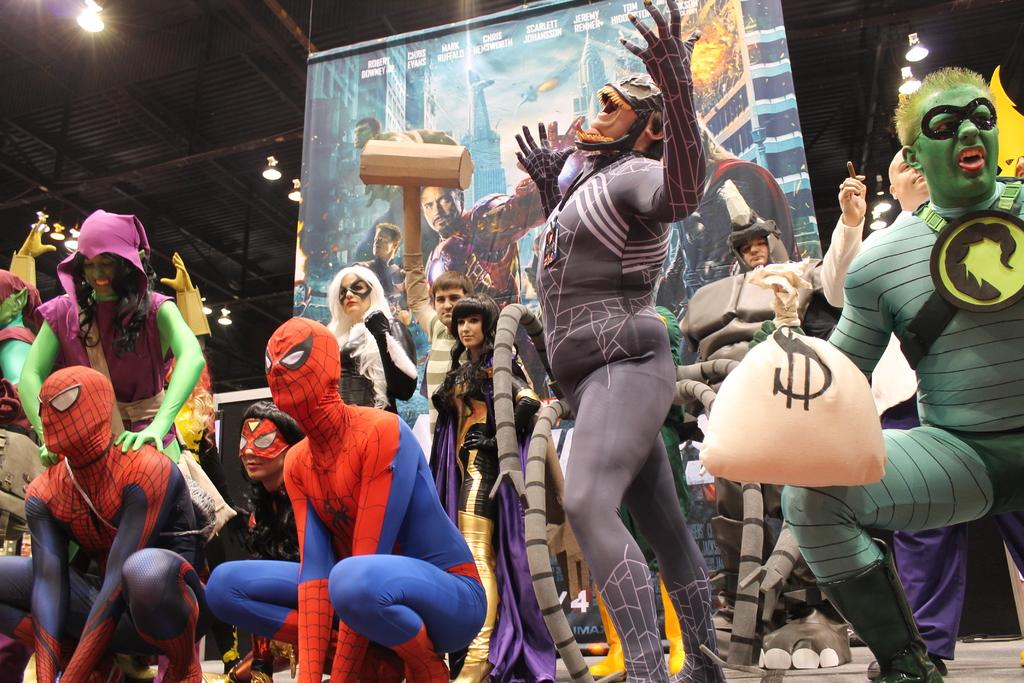Who or what can be seen in the image? There are people in the image. What are the people wearing? The people are wearing costumes. Where are the people standing? The people are standing on the floor. What type of cork is being used to hold the people's costumes together in the image? There is no cork present in the image, and the people's costumes are not being held together by any visible means. 